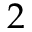Convert formula to latex. <formula><loc_0><loc_0><loc_500><loc_500>2</formula> 